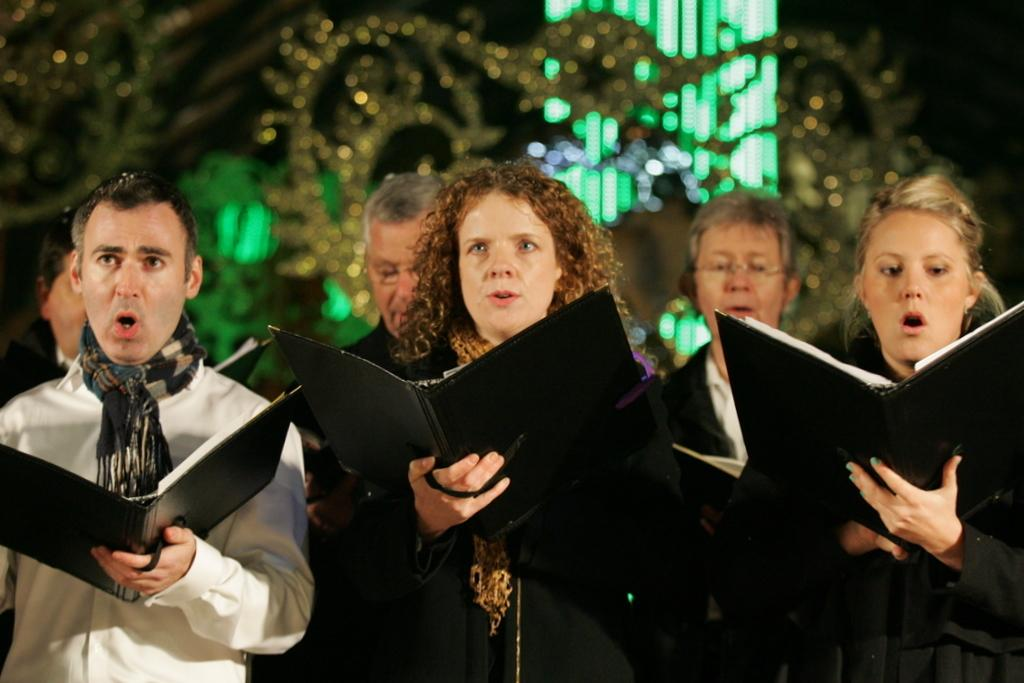What is happening in the foreground of the image? There is a group of people in the foreground of the image. What are the people holding in their hands? The people are holding books in their hands. What can be seen in the background of the image? There are lights and the sky visible in the background of the image. What time of day was the image taken? The image was taken during nighttime. How many spiders are crawling on the books in the image? There are no spiders visible in the image; the people are holding books in their hands. What type of coal is being used to fuel the lights in the background? There is no coal present in the image; the lights are visible in the background, but their source of power is not mentioned. 